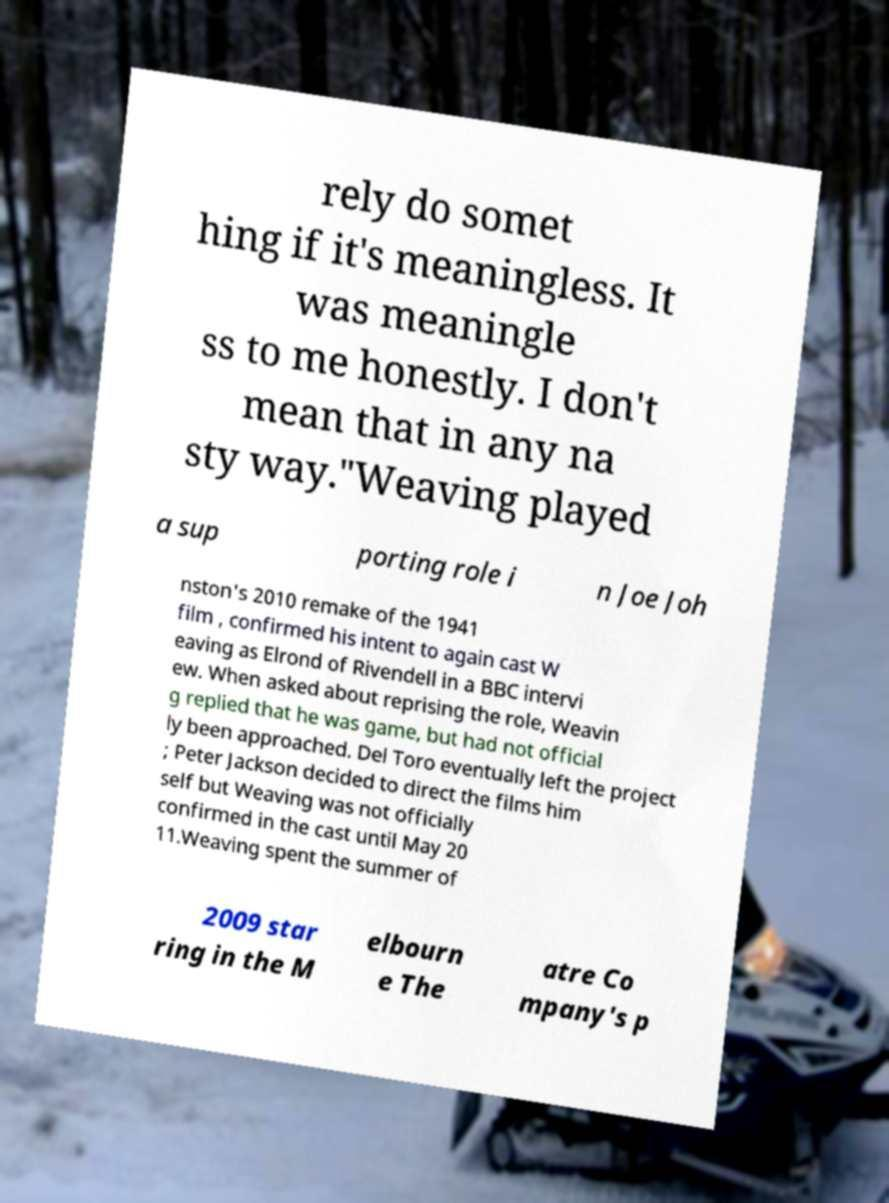Please read and relay the text visible in this image. What does it say? rely do somet hing if it's meaningless. It was meaningle ss to me honestly. I don't mean that in any na sty way."Weaving played a sup porting role i n Joe Joh nston's 2010 remake of the 1941 film , confirmed his intent to again cast W eaving as Elrond of Rivendell in a BBC intervi ew. When asked about reprising the role, Weavin g replied that he was game, but had not official ly been approached. Del Toro eventually left the project ; Peter Jackson decided to direct the films him self but Weaving was not officially confirmed in the cast until May 20 11.Weaving spent the summer of 2009 star ring in the M elbourn e The atre Co mpany's p 